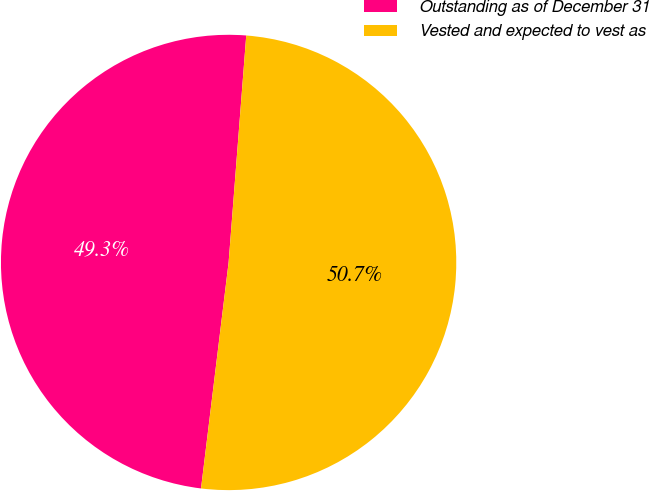<chart> <loc_0><loc_0><loc_500><loc_500><pie_chart><fcel>Outstanding as of December 31<fcel>Vested and expected to vest as<nl><fcel>49.3%<fcel>50.7%<nl></chart> 